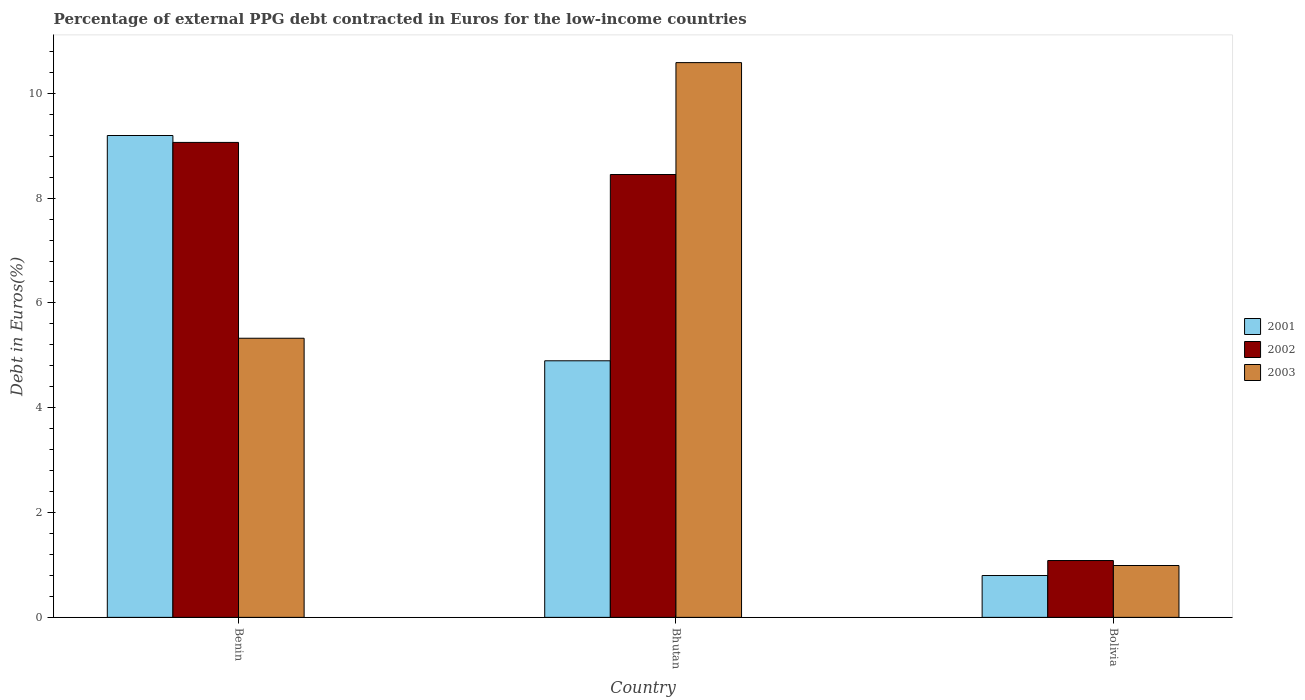Are the number of bars per tick equal to the number of legend labels?
Make the answer very short. Yes. Are the number of bars on each tick of the X-axis equal?
Your response must be concise. Yes. What is the label of the 2nd group of bars from the left?
Your answer should be very brief. Bhutan. What is the percentage of external PPG debt contracted in Euros in 2001 in Bolivia?
Your answer should be very brief. 0.8. Across all countries, what is the maximum percentage of external PPG debt contracted in Euros in 2003?
Offer a terse response. 10.59. Across all countries, what is the minimum percentage of external PPG debt contracted in Euros in 2002?
Ensure brevity in your answer.  1.08. In which country was the percentage of external PPG debt contracted in Euros in 2003 maximum?
Give a very brief answer. Bhutan. In which country was the percentage of external PPG debt contracted in Euros in 2002 minimum?
Make the answer very short. Bolivia. What is the total percentage of external PPG debt contracted in Euros in 2003 in the graph?
Your response must be concise. 16.9. What is the difference between the percentage of external PPG debt contracted in Euros in 2001 in Benin and that in Bolivia?
Provide a succinct answer. 8.4. What is the difference between the percentage of external PPG debt contracted in Euros in 2003 in Bolivia and the percentage of external PPG debt contracted in Euros in 2001 in Bhutan?
Your answer should be very brief. -3.91. What is the average percentage of external PPG debt contracted in Euros in 2003 per country?
Offer a terse response. 5.63. What is the difference between the percentage of external PPG debt contracted in Euros of/in 2003 and percentage of external PPG debt contracted in Euros of/in 2002 in Bolivia?
Give a very brief answer. -0.09. What is the ratio of the percentage of external PPG debt contracted in Euros in 2001 in Benin to that in Bhutan?
Offer a very short reply. 1.88. Is the difference between the percentage of external PPG debt contracted in Euros in 2003 in Benin and Bolivia greater than the difference between the percentage of external PPG debt contracted in Euros in 2002 in Benin and Bolivia?
Offer a very short reply. No. What is the difference between the highest and the second highest percentage of external PPG debt contracted in Euros in 2001?
Your answer should be very brief. -8.4. What is the difference between the highest and the lowest percentage of external PPG debt contracted in Euros in 2001?
Give a very brief answer. 8.4. Is the sum of the percentage of external PPG debt contracted in Euros in 2001 in Bhutan and Bolivia greater than the maximum percentage of external PPG debt contracted in Euros in 2003 across all countries?
Provide a succinct answer. No. What does the 3rd bar from the right in Bolivia represents?
Your answer should be compact. 2001. Is it the case that in every country, the sum of the percentage of external PPG debt contracted in Euros in 2003 and percentage of external PPG debt contracted in Euros in 2001 is greater than the percentage of external PPG debt contracted in Euros in 2002?
Provide a short and direct response. Yes. How many bars are there?
Offer a terse response. 9. What is the difference between two consecutive major ticks on the Y-axis?
Provide a short and direct response. 2. Does the graph contain grids?
Your response must be concise. No. What is the title of the graph?
Provide a succinct answer. Percentage of external PPG debt contracted in Euros for the low-income countries. Does "1983" appear as one of the legend labels in the graph?
Keep it short and to the point. No. What is the label or title of the X-axis?
Ensure brevity in your answer.  Country. What is the label or title of the Y-axis?
Provide a succinct answer. Debt in Euros(%). What is the Debt in Euros(%) of 2001 in Benin?
Ensure brevity in your answer.  9.19. What is the Debt in Euros(%) in 2002 in Benin?
Keep it short and to the point. 9.06. What is the Debt in Euros(%) of 2003 in Benin?
Keep it short and to the point. 5.33. What is the Debt in Euros(%) in 2001 in Bhutan?
Offer a very short reply. 4.9. What is the Debt in Euros(%) of 2002 in Bhutan?
Offer a very short reply. 8.45. What is the Debt in Euros(%) in 2003 in Bhutan?
Give a very brief answer. 10.59. What is the Debt in Euros(%) of 2001 in Bolivia?
Keep it short and to the point. 0.8. What is the Debt in Euros(%) of 2002 in Bolivia?
Ensure brevity in your answer.  1.08. Across all countries, what is the maximum Debt in Euros(%) in 2001?
Keep it short and to the point. 9.19. Across all countries, what is the maximum Debt in Euros(%) of 2002?
Give a very brief answer. 9.06. Across all countries, what is the maximum Debt in Euros(%) of 2003?
Offer a very short reply. 10.59. Across all countries, what is the minimum Debt in Euros(%) of 2001?
Make the answer very short. 0.8. Across all countries, what is the minimum Debt in Euros(%) in 2002?
Your response must be concise. 1.08. What is the total Debt in Euros(%) in 2001 in the graph?
Ensure brevity in your answer.  14.89. What is the total Debt in Euros(%) of 2002 in the graph?
Offer a terse response. 18.6. What is the total Debt in Euros(%) in 2003 in the graph?
Provide a short and direct response. 16.9. What is the difference between the Debt in Euros(%) of 2001 in Benin and that in Bhutan?
Your response must be concise. 4.3. What is the difference between the Debt in Euros(%) of 2002 in Benin and that in Bhutan?
Offer a very short reply. 0.61. What is the difference between the Debt in Euros(%) of 2003 in Benin and that in Bhutan?
Provide a short and direct response. -5.26. What is the difference between the Debt in Euros(%) of 2001 in Benin and that in Bolivia?
Provide a succinct answer. 8.4. What is the difference between the Debt in Euros(%) in 2002 in Benin and that in Bolivia?
Your answer should be compact. 7.98. What is the difference between the Debt in Euros(%) in 2003 in Benin and that in Bolivia?
Give a very brief answer. 4.34. What is the difference between the Debt in Euros(%) in 2001 in Bhutan and that in Bolivia?
Your answer should be very brief. 4.1. What is the difference between the Debt in Euros(%) in 2002 in Bhutan and that in Bolivia?
Offer a terse response. 7.37. What is the difference between the Debt in Euros(%) in 2003 in Bhutan and that in Bolivia?
Give a very brief answer. 9.6. What is the difference between the Debt in Euros(%) of 2001 in Benin and the Debt in Euros(%) of 2002 in Bhutan?
Make the answer very short. 0.74. What is the difference between the Debt in Euros(%) in 2001 in Benin and the Debt in Euros(%) in 2003 in Bhutan?
Your answer should be very brief. -1.39. What is the difference between the Debt in Euros(%) in 2002 in Benin and the Debt in Euros(%) in 2003 in Bhutan?
Provide a succinct answer. -1.52. What is the difference between the Debt in Euros(%) of 2001 in Benin and the Debt in Euros(%) of 2002 in Bolivia?
Keep it short and to the point. 8.11. What is the difference between the Debt in Euros(%) of 2001 in Benin and the Debt in Euros(%) of 2003 in Bolivia?
Provide a succinct answer. 8.21. What is the difference between the Debt in Euros(%) of 2002 in Benin and the Debt in Euros(%) of 2003 in Bolivia?
Make the answer very short. 8.07. What is the difference between the Debt in Euros(%) in 2001 in Bhutan and the Debt in Euros(%) in 2002 in Bolivia?
Your response must be concise. 3.81. What is the difference between the Debt in Euros(%) of 2001 in Bhutan and the Debt in Euros(%) of 2003 in Bolivia?
Provide a short and direct response. 3.91. What is the difference between the Debt in Euros(%) of 2002 in Bhutan and the Debt in Euros(%) of 2003 in Bolivia?
Keep it short and to the point. 7.46. What is the average Debt in Euros(%) in 2001 per country?
Ensure brevity in your answer.  4.96. What is the average Debt in Euros(%) in 2002 per country?
Keep it short and to the point. 6.2. What is the average Debt in Euros(%) of 2003 per country?
Provide a succinct answer. 5.63. What is the difference between the Debt in Euros(%) of 2001 and Debt in Euros(%) of 2002 in Benin?
Ensure brevity in your answer.  0.13. What is the difference between the Debt in Euros(%) of 2001 and Debt in Euros(%) of 2003 in Benin?
Make the answer very short. 3.87. What is the difference between the Debt in Euros(%) in 2002 and Debt in Euros(%) in 2003 in Benin?
Your response must be concise. 3.74. What is the difference between the Debt in Euros(%) in 2001 and Debt in Euros(%) in 2002 in Bhutan?
Your answer should be very brief. -3.55. What is the difference between the Debt in Euros(%) in 2001 and Debt in Euros(%) in 2003 in Bhutan?
Offer a very short reply. -5.69. What is the difference between the Debt in Euros(%) in 2002 and Debt in Euros(%) in 2003 in Bhutan?
Offer a terse response. -2.14. What is the difference between the Debt in Euros(%) of 2001 and Debt in Euros(%) of 2002 in Bolivia?
Give a very brief answer. -0.29. What is the difference between the Debt in Euros(%) of 2001 and Debt in Euros(%) of 2003 in Bolivia?
Your answer should be compact. -0.19. What is the difference between the Debt in Euros(%) of 2002 and Debt in Euros(%) of 2003 in Bolivia?
Offer a very short reply. 0.09. What is the ratio of the Debt in Euros(%) in 2001 in Benin to that in Bhutan?
Your answer should be compact. 1.88. What is the ratio of the Debt in Euros(%) of 2002 in Benin to that in Bhutan?
Make the answer very short. 1.07. What is the ratio of the Debt in Euros(%) in 2003 in Benin to that in Bhutan?
Offer a very short reply. 0.5. What is the ratio of the Debt in Euros(%) in 2001 in Benin to that in Bolivia?
Give a very brief answer. 11.52. What is the ratio of the Debt in Euros(%) of 2002 in Benin to that in Bolivia?
Provide a short and direct response. 8.36. What is the ratio of the Debt in Euros(%) in 2003 in Benin to that in Bolivia?
Offer a terse response. 5.38. What is the ratio of the Debt in Euros(%) of 2001 in Bhutan to that in Bolivia?
Offer a very short reply. 6.13. What is the ratio of the Debt in Euros(%) in 2002 in Bhutan to that in Bolivia?
Give a very brief answer. 7.79. What is the ratio of the Debt in Euros(%) of 2003 in Bhutan to that in Bolivia?
Make the answer very short. 10.7. What is the difference between the highest and the second highest Debt in Euros(%) in 2001?
Ensure brevity in your answer.  4.3. What is the difference between the highest and the second highest Debt in Euros(%) of 2002?
Your answer should be very brief. 0.61. What is the difference between the highest and the second highest Debt in Euros(%) in 2003?
Your response must be concise. 5.26. What is the difference between the highest and the lowest Debt in Euros(%) in 2001?
Provide a short and direct response. 8.4. What is the difference between the highest and the lowest Debt in Euros(%) of 2002?
Ensure brevity in your answer.  7.98. What is the difference between the highest and the lowest Debt in Euros(%) in 2003?
Your response must be concise. 9.6. 